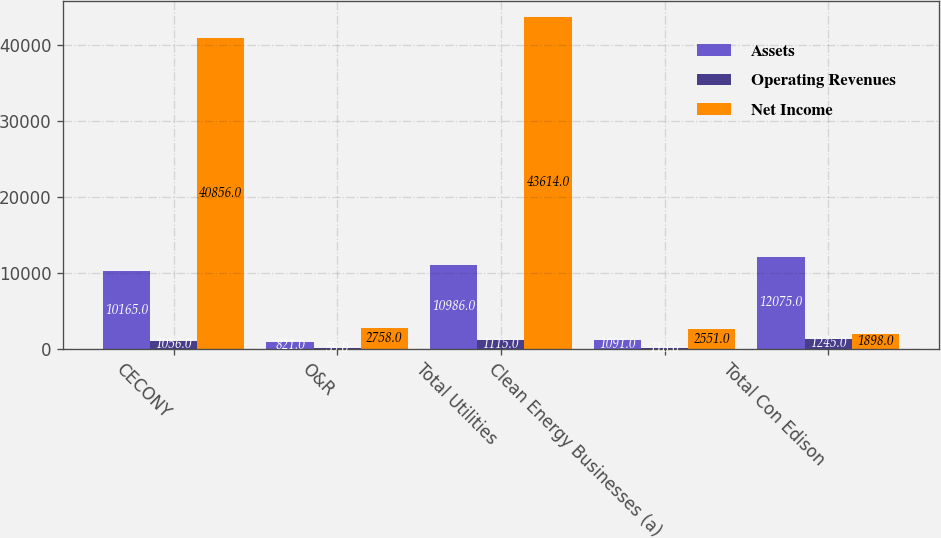<chart> <loc_0><loc_0><loc_500><loc_500><stacked_bar_chart><ecel><fcel>CECONY<fcel>O&R<fcel>Total Utilities<fcel>Clean Energy Businesses (a)<fcel>Total Con Edison<nl><fcel>Assets<fcel>10165<fcel>821<fcel>10986<fcel>1091<fcel>12075<nl><fcel>Operating Revenues<fcel>1056<fcel>59<fcel>1115<fcel>118<fcel>1245<nl><fcel>Net Income<fcel>40856<fcel>2758<fcel>43614<fcel>2551<fcel>1898<nl></chart> 